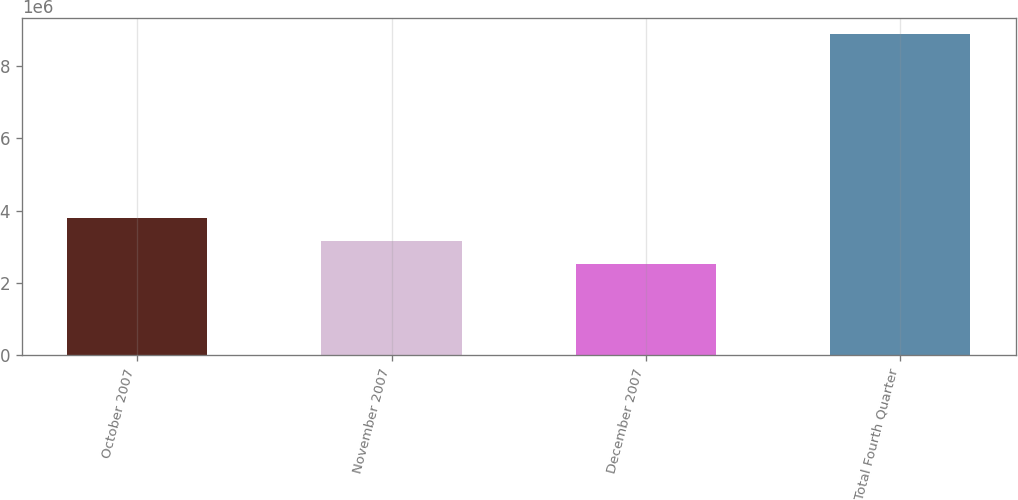Convert chart. <chart><loc_0><loc_0><loc_500><loc_500><bar_chart><fcel>October 2007<fcel>November 2007<fcel>December 2007<fcel>Total Fourth Quarter<nl><fcel>3.78745e+06<fcel>3.14894e+06<fcel>2.51042e+06<fcel>8.89557e+06<nl></chart> 